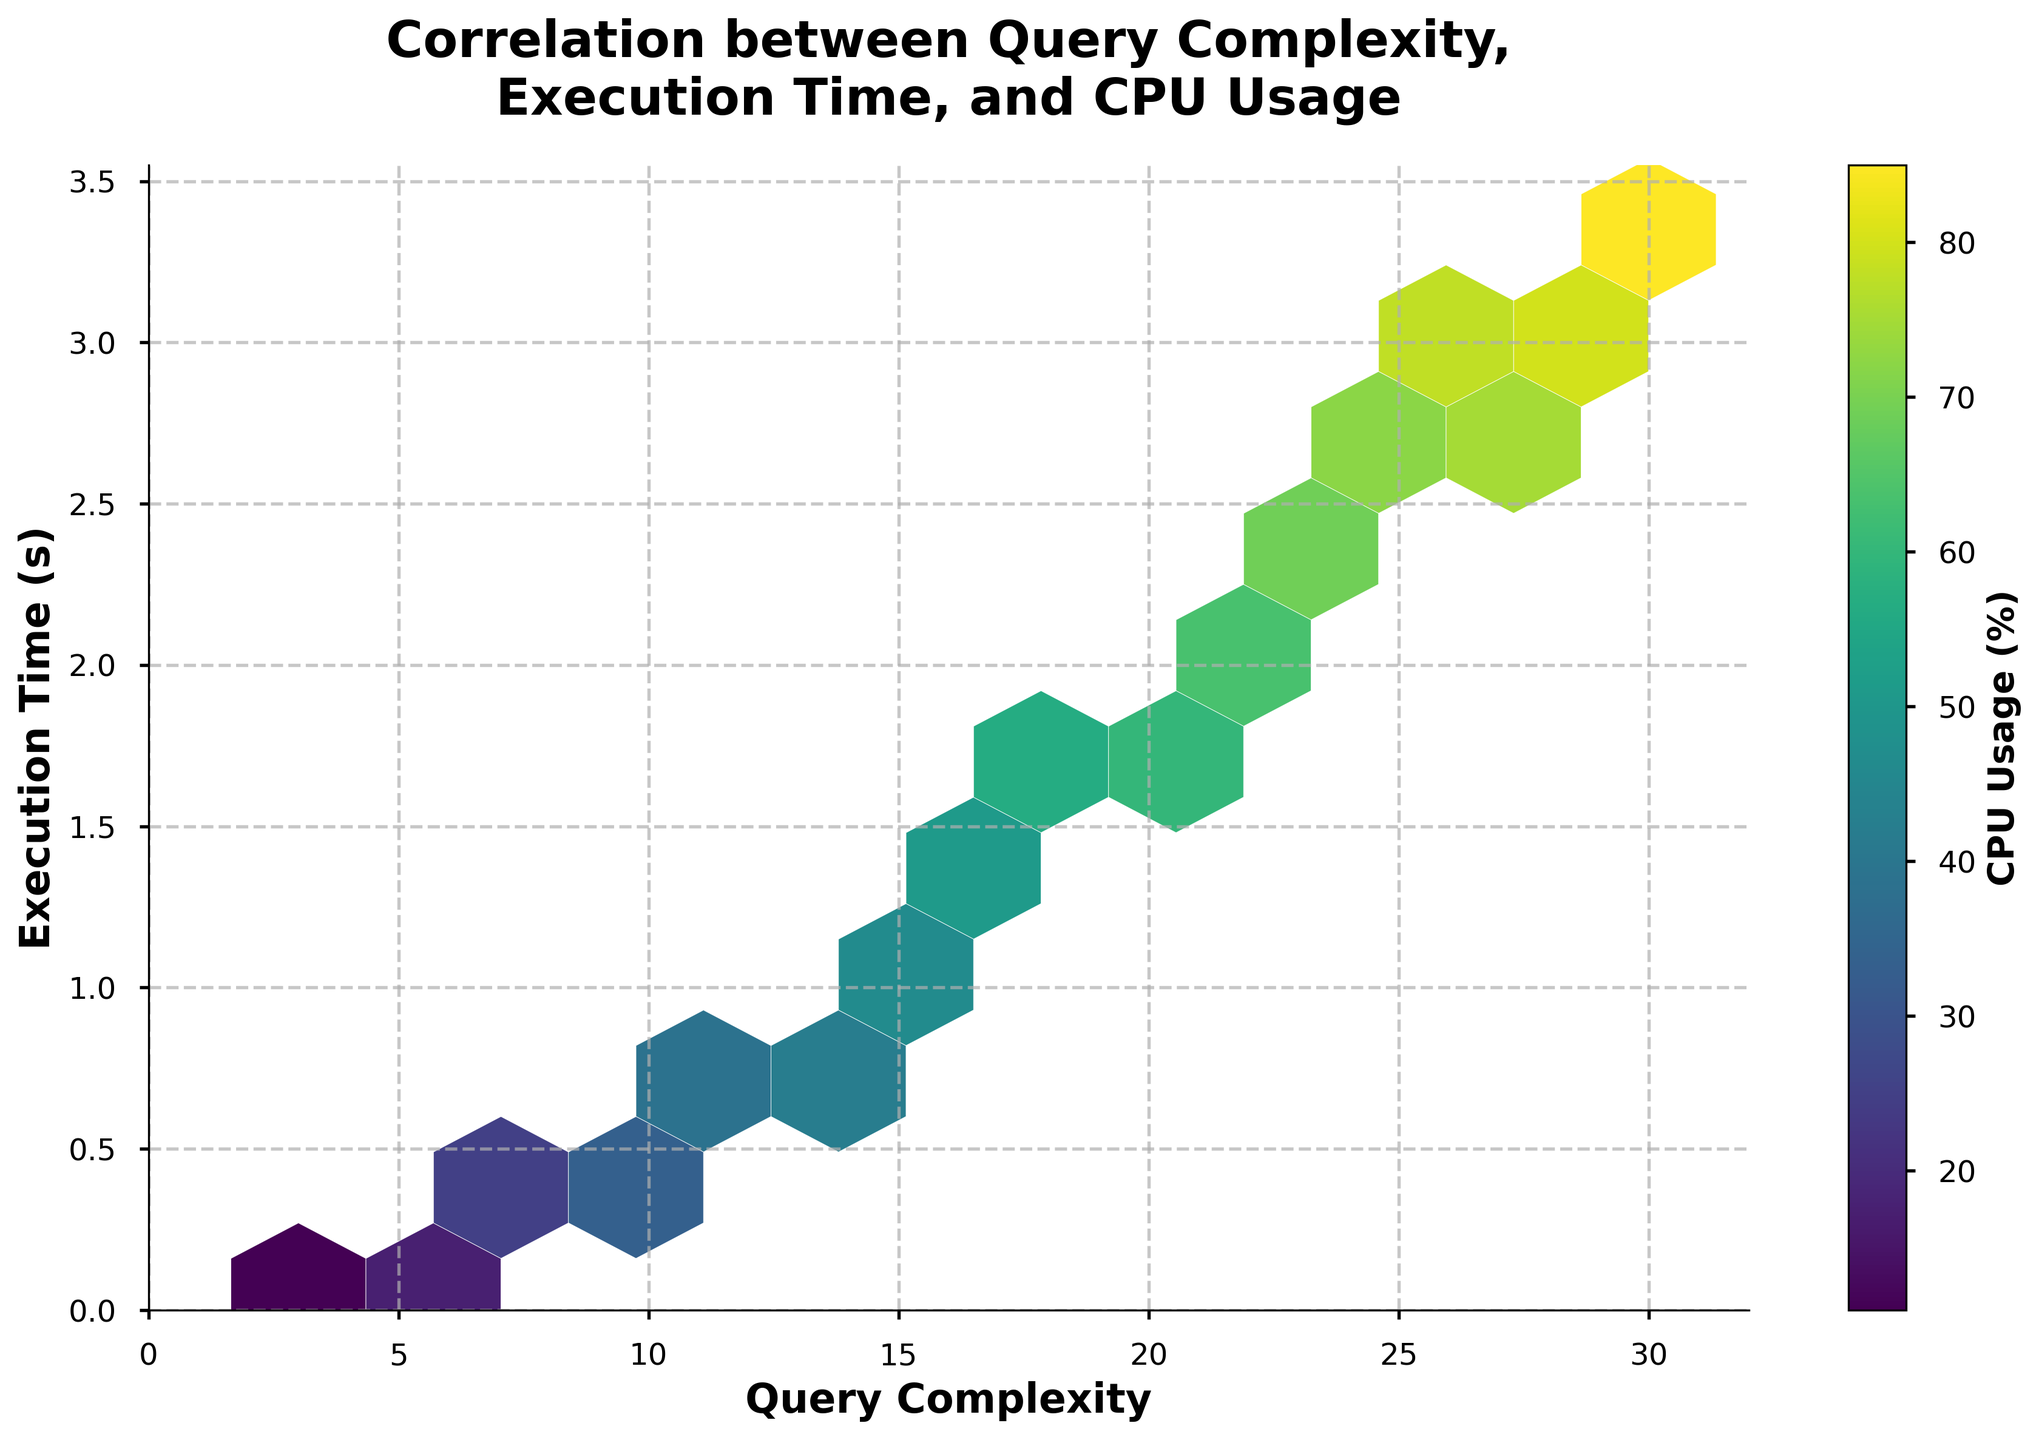What is the title of the figure? The title of the figure is displayed at the top and reads "Correlation between Query Complexity, Execution Time, and CPU Usage".
Answer: Correlation between Query Complexity, Execution Time, and CPU Usage What color represents the lowest CPU usage on the color bar? The color bar uses the 'viridis' color map, where the lowest CPU usage is represented by the dark purple color.
Answer: Dark purple What are the units used for the x-axis and y-axis? The x-axis represents "Query Complexity" which has no specific unit. The y-axis represents "Execution Time" measured in seconds (s).
Answer: Query Complexity and seconds How many grid cells have at least one data point? By looking at the hexbin areas, there are multiple grid cells with hexagons filled with color. Counting these can vary by eyesight, but approximately 8-10 cells have at least one data point.
Answer: Approximately 8-10 Which query complexity has the longest execution time? The point with the highest value on the y-axis (Execution Time) corresponds to the highest x-axis value (Query Complexity). The query complexity with the longest execution time is 30.
Answer: 30 What is the approximate CPU usage at the highest execution time? Find the hexagon at the highest point on the y-axis and observe its color. The color indicates a CPU usage of approximately 85% as per the color bar.
Answer: Approximately 85% Which range of query complexity has the highest CPU usage? The highest CPU usage, represented by the bright yellow-green color, corresponds to the upper range of query complexity. This range is around 25-30.
Answer: Around 25-30 Comparing the central data points, is CPU usage more influenced by query complexity or execution time? Observing the denser center regions, the color gradient shows a closer correlation between CPU usage and query complexity rather than execution time.
Answer: Query complexity Do small queries (low complexity) always correspond to low CPU usage and short execution time? Small queries are located towards the lower region on the x-axis and usually show purple colors indicating low CPU usage and short execution times, but with increasing complexity, the shades change. So not always, but often.
Answer: Not always, but often 